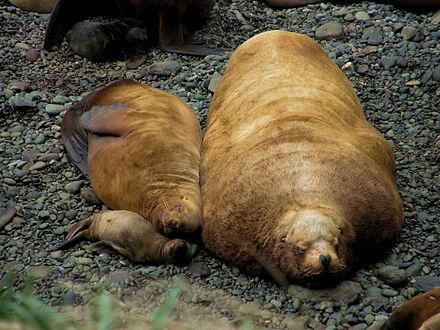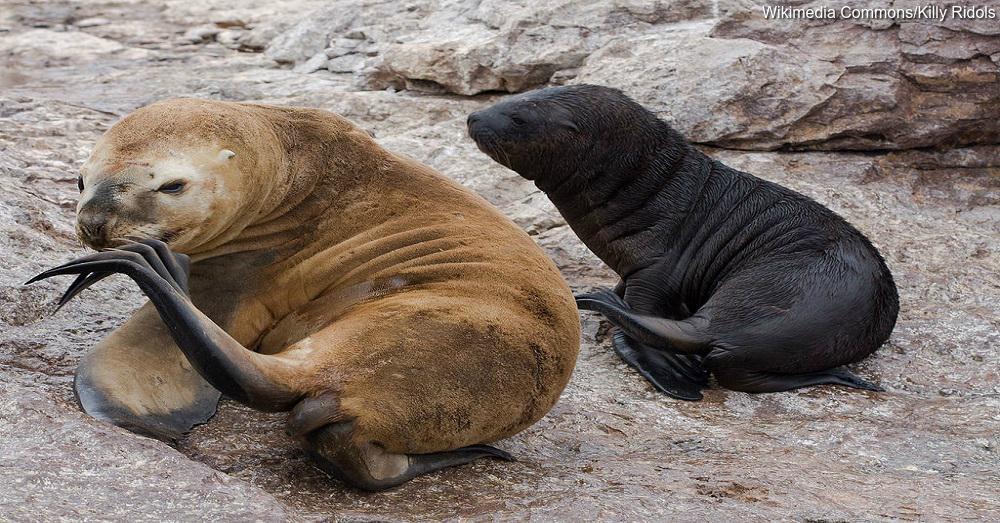The first image is the image on the left, the second image is the image on the right. Considering the images on both sides, is "There are exactly two seals in the right image." valid? Answer yes or no. Yes. The first image is the image on the left, the second image is the image on the right. Considering the images on both sides, is "A black seal is sitting to the right of a brown seal." valid? Answer yes or no. Yes. 